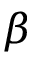<formula> <loc_0><loc_0><loc_500><loc_500>\beta</formula> 